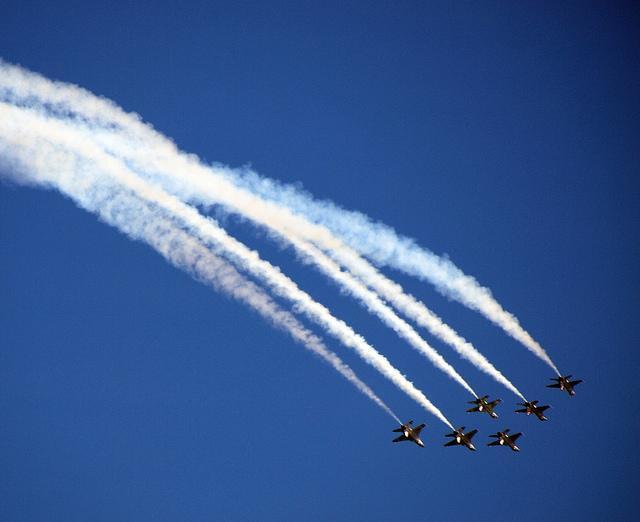How many planes?
Give a very brief answer. 6. How many stuffed bears are there?
Give a very brief answer. 0. 